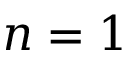<formula> <loc_0><loc_0><loc_500><loc_500>n = 1</formula> 